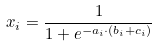<formula> <loc_0><loc_0><loc_500><loc_500>x _ { i } = \frac { 1 } { 1 + e ^ { - a _ { i } \cdot ( b _ { i } + c _ { i } ) } }</formula> 